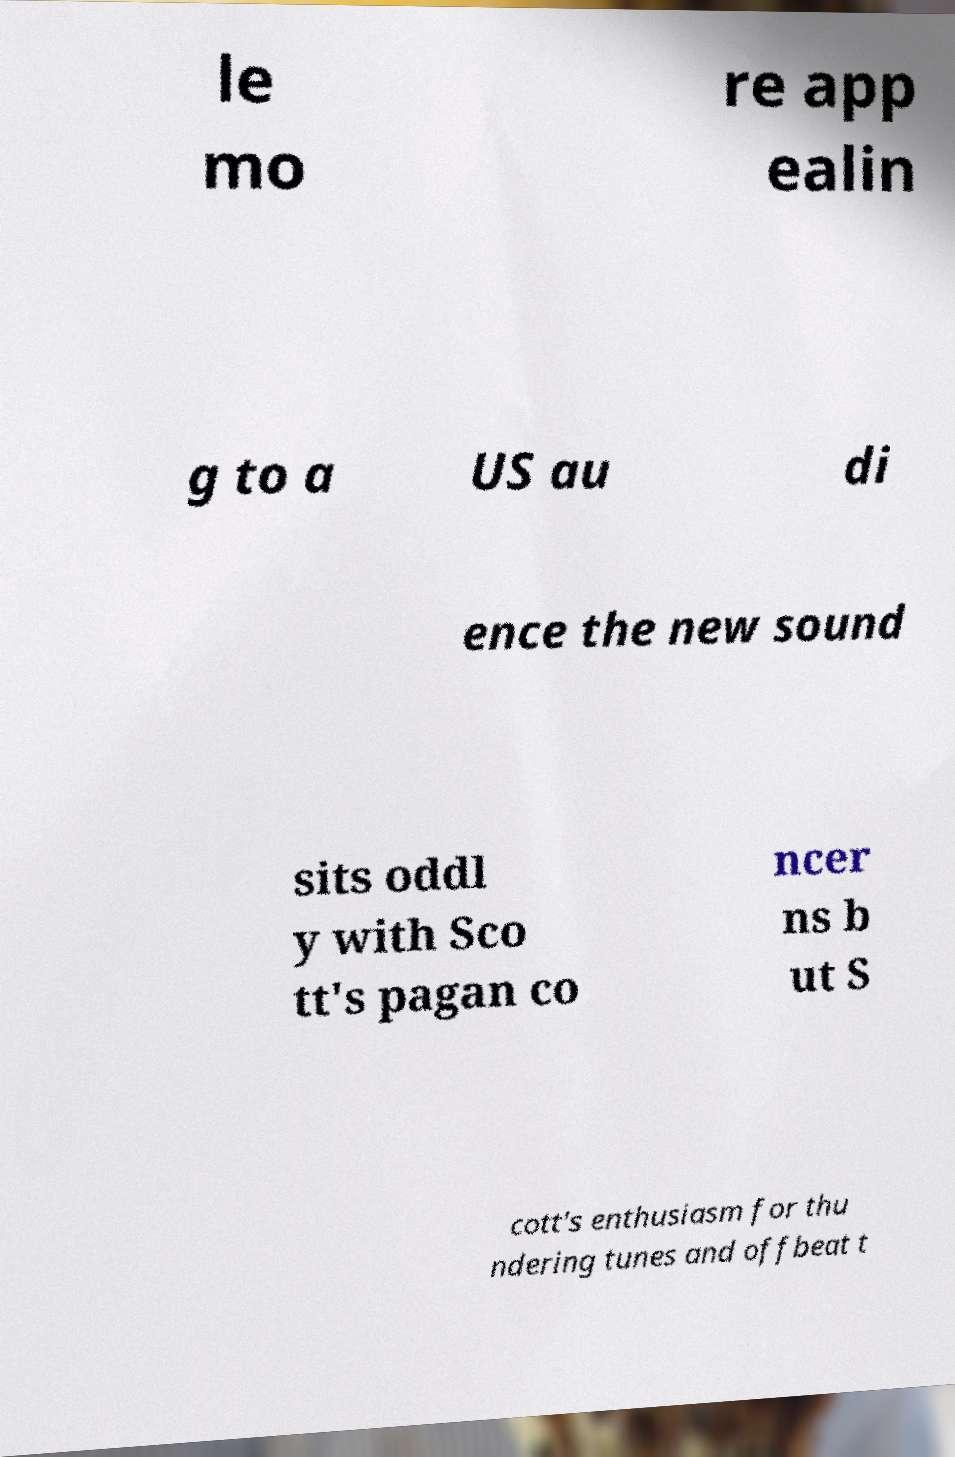Can you accurately transcribe the text from the provided image for me? le mo re app ealin g to a US au di ence the new sound sits oddl y with Sco tt's pagan co ncer ns b ut S cott's enthusiasm for thu ndering tunes and offbeat t 